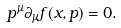Convert formula to latex. <formula><loc_0><loc_0><loc_500><loc_500>p ^ { \mu } \partial _ { \mu } f ( x , p ) = 0 .</formula> 